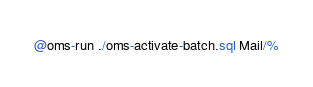<code> <loc_0><loc_0><loc_500><loc_500><_SQL_>@oms-run ./oms-activate-batch.sql Mail/%
</code> 